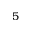Convert formula to latex. <formula><loc_0><loc_0><loc_500><loc_500>5</formula> 